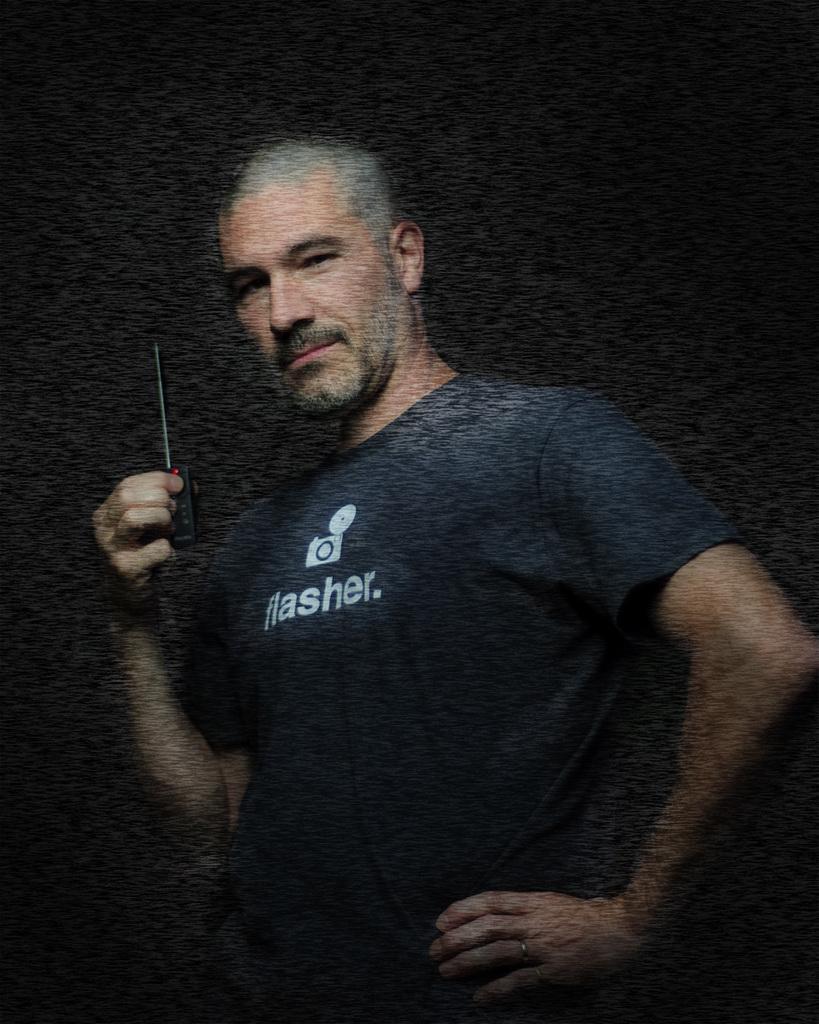Describe this image in one or two sentences. In this image we can see a person wearing t shirt is holding a device in his hand. 